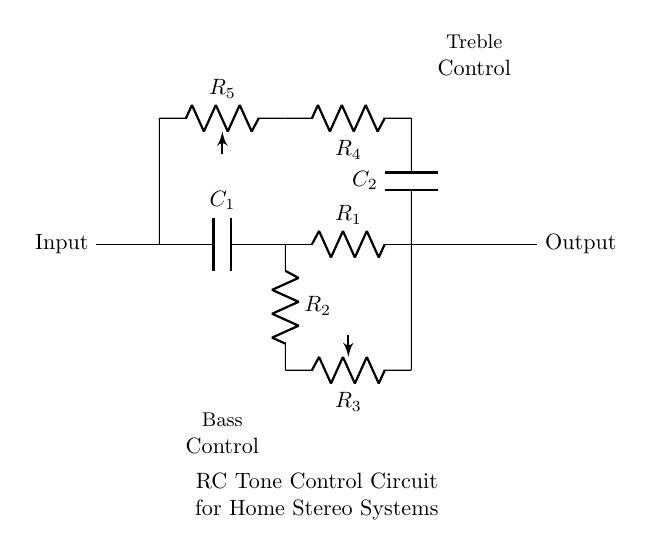What are the components in this circuit? The circuit contains capacitors, resistors, and potentiometers. Specifically, there are two capacitors (C1 and C2), four resistors (R1, R2, R4, and R5), and two potentiometers (R3 and R5) used for bass and treble controls.
Answer: capacitors, resistors, potentiometers What does the label "Bass Control" indicate? The label "Bass Control" indicates the section of the circuit responsible for adjusting the bass frequencies. This is typically achieved by modifying the values of the components in that section, affecting the signal processing for lower frequency sounds.
Answer: Bass frequencies adjustment Which resistor is associated with the treble control? The resistor R4 is associated with the treble control; it connects C2 and the potentiometer R5 to the upper section of the circuit. This resistor influences the high-frequency response of the audio signal.
Answer: R4 What happens to the output signal when R3 is increased? When R3 is increased, it reduces the current flowing through that path, effectively decreasing the bass response. This modification alters the frequency response, filtering out lower frequencies from the output signal.
Answer: Decreased bass response How many capacitors are in the circuit? There are two capacitors (C1 and C2) in the circuit that are critical for adjusting the frequency response by storing energy and filtering signal frequencies.
Answer: 2 What role does R2 play in this circuit? R2 forms part of the bass control section, working together with C1 to define the cutoff frequency for bass signals. As part of an RC network, it influences how the circuit responds to low-frequency signals.
Answer: Defines cutoff frequency for bass What does the presence of potentiometers in this circuit indicate? The presence of potentiometers indicates that the circuit allows for variable adjustment of resistance, enabling users to tailor their audio settings for bass and treble according to their preferences.
Answer: Variable resistance adjustment 